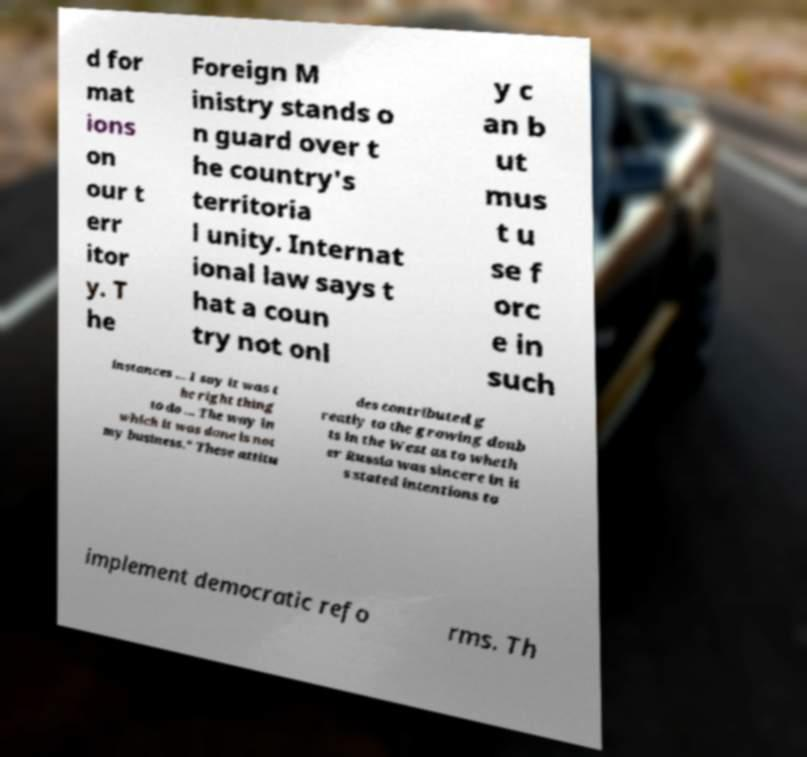Please identify and transcribe the text found in this image. d for mat ions on our t err itor y. T he Foreign M inistry stands o n guard over t he country's territoria l unity. Internat ional law says t hat a coun try not onl y c an b ut mus t u se f orc e in such instances ... I say it was t he right thing to do ... The way in which it was done is not my business." These attitu des contributed g reatly to the growing doub ts in the West as to wheth er Russia was sincere in it s stated intentions to implement democratic refo rms. Th 